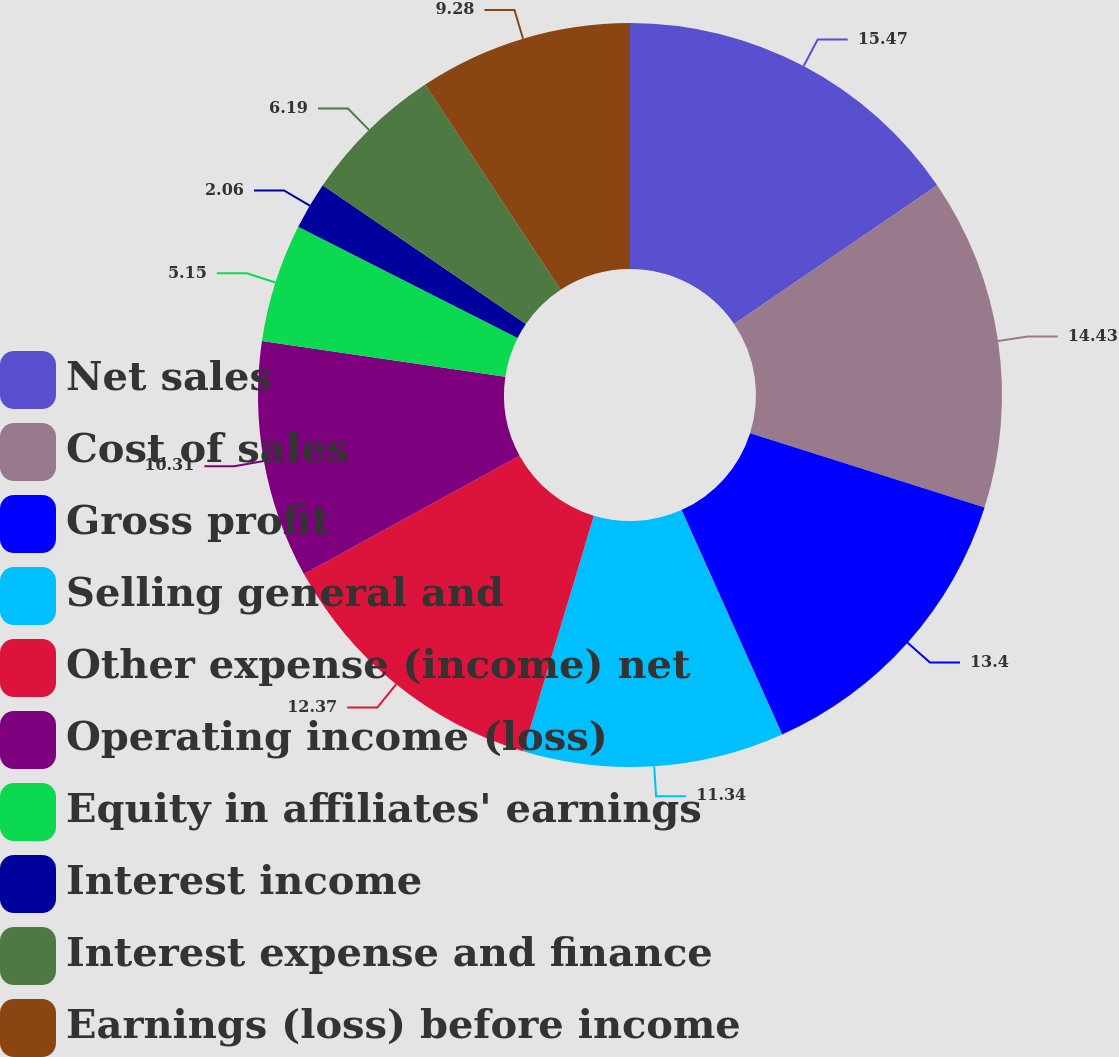<chart> <loc_0><loc_0><loc_500><loc_500><pie_chart><fcel>Net sales<fcel>Cost of sales<fcel>Gross profit<fcel>Selling general and<fcel>Other expense (income) net<fcel>Operating income (loss)<fcel>Equity in affiliates' earnings<fcel>Interest income<fcel>Interest expense and finance<fcel>Earnings (loss) before income<nl><fcel>15.46%<fcel>14.43%<fcel>13.4%<fcel>11.34%<fcel>12.37%<fcel>10.31%<fcel>5.15%<fcel>2.06%<fcel>6.19%<fcel>9.28%<nl></chart> 